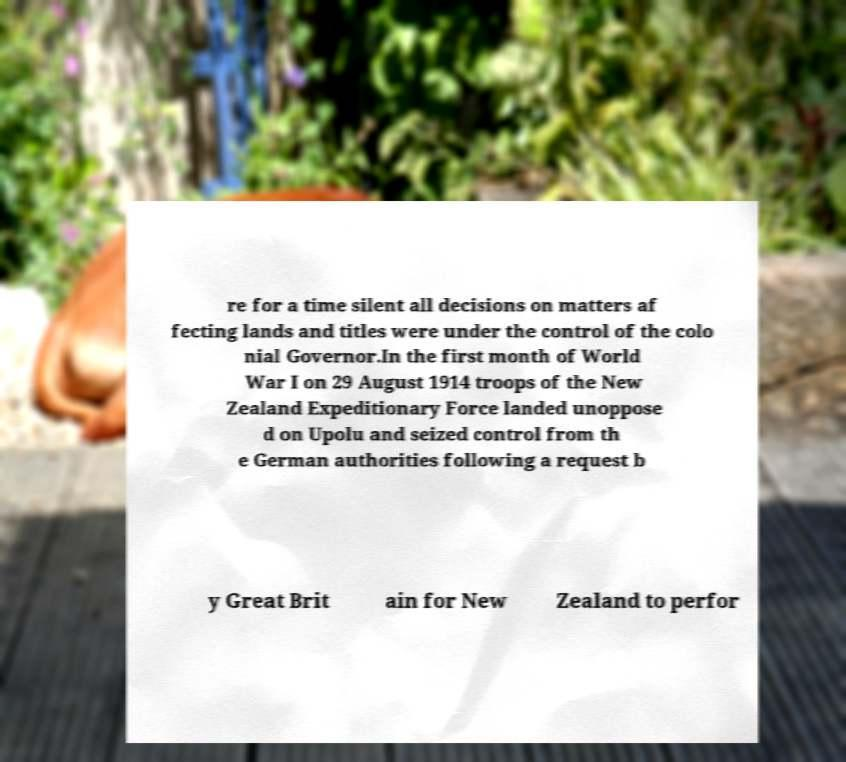Can you accurately transcribe the text from the provided image for me? re for a time silent all decisions on matters af fecting lands and titles were under the control of the colo nial Governor.In the first month of World War I on 29 August 1914 troops of the New Zealand Expeditionary Force landed unoppose d on Upolu and seized control from th e German authorities following a request b y Great Brit ain for New Zealand to perfor 